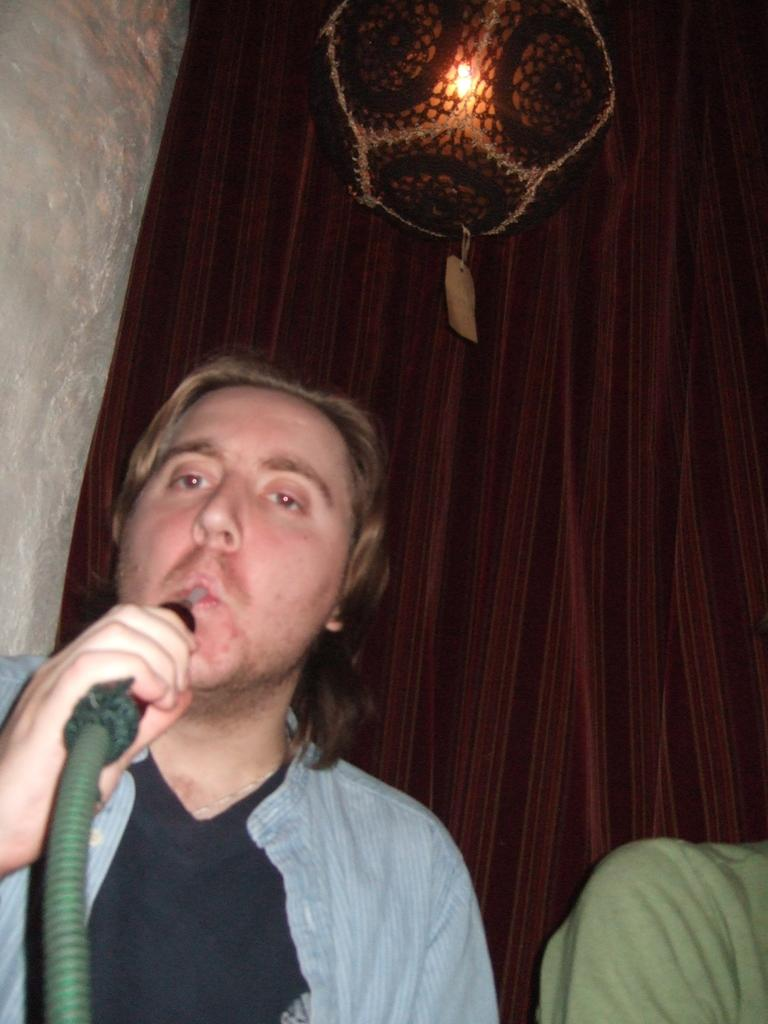What is the person in the image holding? The person in the image is holding a pipe. Can you describe the other person in the image? There is another person in the image, but no specific details are provided about them. What can be seen in the background of the image? There is a curtain, a wall, and a light in the background of the image. What type of plantation is visible in the image? There is no plantation present in the image. 